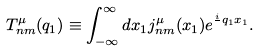<formula> <loc_0><loc_0><loc_500><loc_500>T _ { n m } ^ { \mu } ( q _ { 1 } ) \equiv \int _ { - \infty } ^ { \infty } d x _ { 1 } j _ { n m } ^ { \mu } ( x _ { 1 } ) e ^ { \frac { i } { } q _ { 1 } x _ { 1 } } .</formula> 